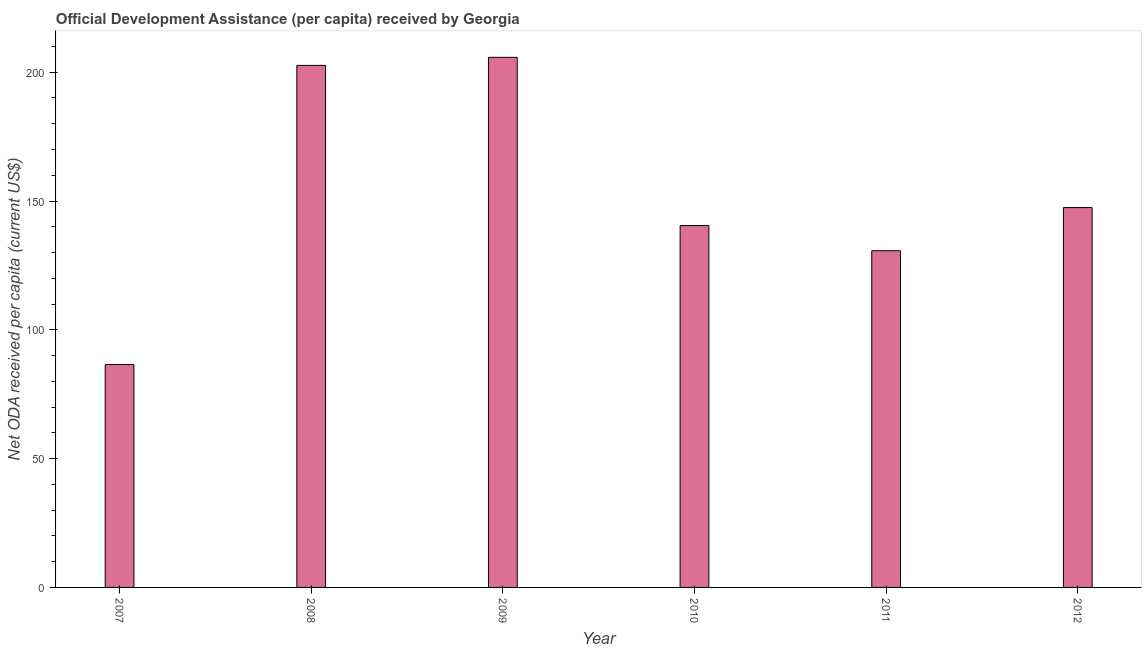Does the graph contain any zero values?
Your answer should be compact. No. Does the graph contain grids?
Offer a very short reply. No. What is the title of the graph?
Ensure brevity in your answer.  Official Development Assistance (per capita) received by Georgia. What is the label or title of the X-axis?
Provide a succinct answer. Year. What is the label or title of the Y-axis?
Provide a short and direct response. Net ODA received per capita (current US$). What is the net oda received per capita in 2009?
Offer a terse response. 205.79. Across all years, what is the maximum net oda received per capita?
Your response must be concise. 205.79. Across all years, what is the minimum net oda received per capita?
Keep it short and to the point. 86.51. In which year was the net oda received per capita minimum?
Your response must be concise. 2007. What is the sum of the net oda received per capita?
Offer a very short reply. 913.59. What is the difference between the net oda received per capita in 2007 and 2009?
Your answer should be very brief. -119.27. What is the average net oda received per capita per year?
Make the answer very short. 152.26. What is the median net oda received per capita?
Provide a succinct answer. 143.97. In how many years, is the net oda received per capita greater than 100 US$?
Provide a succinct answer. 5. What is the ratio of the net oda received per capita in 2007 to that in 2008?
Your answer should be compact. 0.43. Is the difference between the net oda received per capita in 2009 and 2012 greater than the difference between any two years?
Offer a very short reply. No. What is the difference between the highest and the second highest net oda received per capita?
Offer a very short reply. 3.13. What is the difference between the highest and the lowest net oda received per capita?
Offer a terse response. 119.27. In how many years, is the net oda received per capita greater than the average net oda received per capita taken over all years?
Your answer should be very brief. 2. How many bars are there?
Keep it short and to the point. 6. Are all the bars in the graph horizontal?
Provide a succinct answer. No. What is the difference between two consecutive major ticks on the Y-axis?
Keep it short and to the point. 50. Are the values on the major ticks of Y-axis written in scientific E-notation?
Provide a succinct answer. No. What is the Net ODA received per capita (current US$) in 2007?
Make the answer very short. 86.51. What is the Net ODA received per capita (current US$) of 2008?
Keep it short and to the point. 202.65. What is the Net ODA received per capita (current US$) of 2009?
Provide a succinct answer. 205.79. What is the Net ODA received per capita (current US$) in 2010?
Offer a terse response. 140.47. What is the Net ODA received per capita (current US$) of 2011?
Provide a short and direct response. 130.7. What is the Net ODA received per capita (current US$) in 2012?
Make the answer very short. 147.46. What is the difference between the Net ODA received per capita (current US$) in 2007 and 2008?
Your answer should be very brief. -116.14. What is the difference between the Net ODA received per capita (current US$) in 2007 and 2009?
Offer a terse response. -119.27. What is the difference between the Net ODA received per capita (current US$) in 2007 and 2010?
Give a very brief answer. -53.96. What is the difference between the Net ODA received per capita (current US$) in 2007 and 2011?
Ensure brevity in your answer.  -44.19. What is the difference between the Net ODA received per capita (current US$) in 2007 and 2012?
Make the answer very short. -60.95. What is the difference between the Net ODA received per capita (current US$) in 2008 and 2009?
Your response must be concise. -3.13. What is the difference between the Net ODA received per capita (current US$) in 2008 and 2010?
Make the answer very short. 62.18. What is the difference between the Net ODA received per capita (current US$) in 2008 and 2011?
Your answer should be very brief. 71.95. What is the difference between the Net ODA received per capita (current US$) in 2008 and 2012?
Make the answer very short. 55.19. What is the difference between the Net ODA received per capita (current US$) in 2009 and 2010?
Your answer should be very brief. 65.31. What is the difference between the Net ODA received per capita (current US$) in 2009 and 2011?
Provide a short and direct response. 75.08. What is the difference between the Net ODA received per capita (current US$) in 2009 and 2012?
Ensure brevity in your answer.  58.32. What is the difference between the Net ODA received per capita (current US$) in 2010 and 2011?
Your answer should be very brief. 9.77. What is the difference between the Net ODA received per capita (current US$) in 2010 and 2012?
Offer a very short reply. -6.99. What is the difference between the Net ODA received per capita (current US$) in 2011 and 2012?
Ensure brevity in your answer.  -16.76. What is the ratio of the Net ODA received per capita (current US$) in 2007 to that in 2008?
Give a very brief answer. 0.43. What is the ratio of the Net ODA received per capita (current US$) in 2007 to that in 2009?
Offer a terse response. 0.42. What is the ratio of the Net ODA received per capita (current US$) in 2007 to that in 2010?
Ensure brevity in your answer.  0.62. What is the ratio of the Net ODA received per capita (current US$) in 2007 to that in 2011?
Your answer should be compact. 0.66. What is the ratio of the Net ODA received per capita (current US$) in 2007 to that in 2012?
Offer a very short reply. 0.59. What is the ratio of the Net ODA received per capita (current US$) in 2008 to that in 2009?
Your response must be concise. 0.98. What is the ratio of the Net ODA received per capita (current US$) in 2008 to that in 2010?
Ensure brevity in your answer.  1.44. What is the ratio of the Net ODA received per capita (current US$) in 2008 to that in 2011?
Offer a very short reply. 1.55. What is the ratio of the Net ODA received per capita (current US$) in 2008 to that in 2012?
Make the answer very short. 1.37. What is the ratio of the Net ODA received per capita (current US$) in 2009 to that in 2010?
Keep it short and to the point. 1.47. What is the ratio of the Net ODA received per capita (current US$) in 2009 to that in 2011?
Provide a succinct answer. 1.57. What is the ratio of the Net ODA received per capita (current US$) in 2009 to that in 2012?
Your response must be concise. 1.4. What is the ratio of the Net ODA received per capita (current US$) in 2010 to that in 2011?
Provide a succinct answer. 1.07. What is the ratio of the Net ODA received per capita (current US$) in 2010 to that in 2012?
Provide a succinct answer. 0.95. What is the ratio of the Net ODA received per capita (current US$) in 2011 to that in 2012?
Make the answer very short. 0.89. 